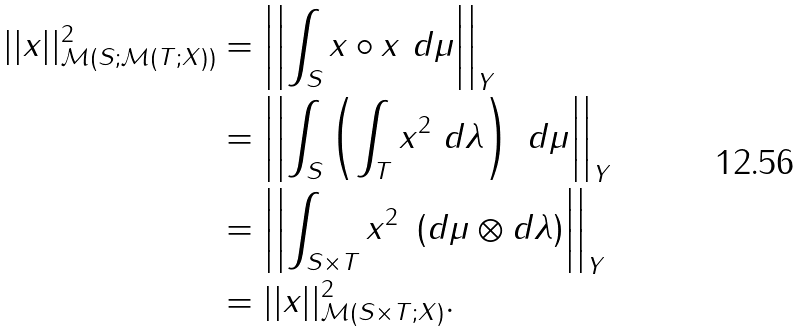<formula> <loc_0><loc_0><loc_500><loc_500>| | x | | _ { \mathcal { M } ( S ; \mathcal { M } ( T ; X ) ) } ^ { 2 } & = \left | \left | \int _ { S } x \circ x \ d \mu \right | \right | _ { Y } \\ & = \left | \left | \int _ { S } \left ( \int _ { T } x ^ { 2 } \ d \lambda \right ) \ d \mu \right | \right | _ { Y } \\ & = \left | \left | \int _ { S \times T } x ^ { 2 } \ \left ( d \mu \otimes d \lambda \right ) \right | \right | _ { Y } \\ & = | | x | | _ { \mathcal { M } ( S \times T ; X ) } ^ { 2 } .</formula> 